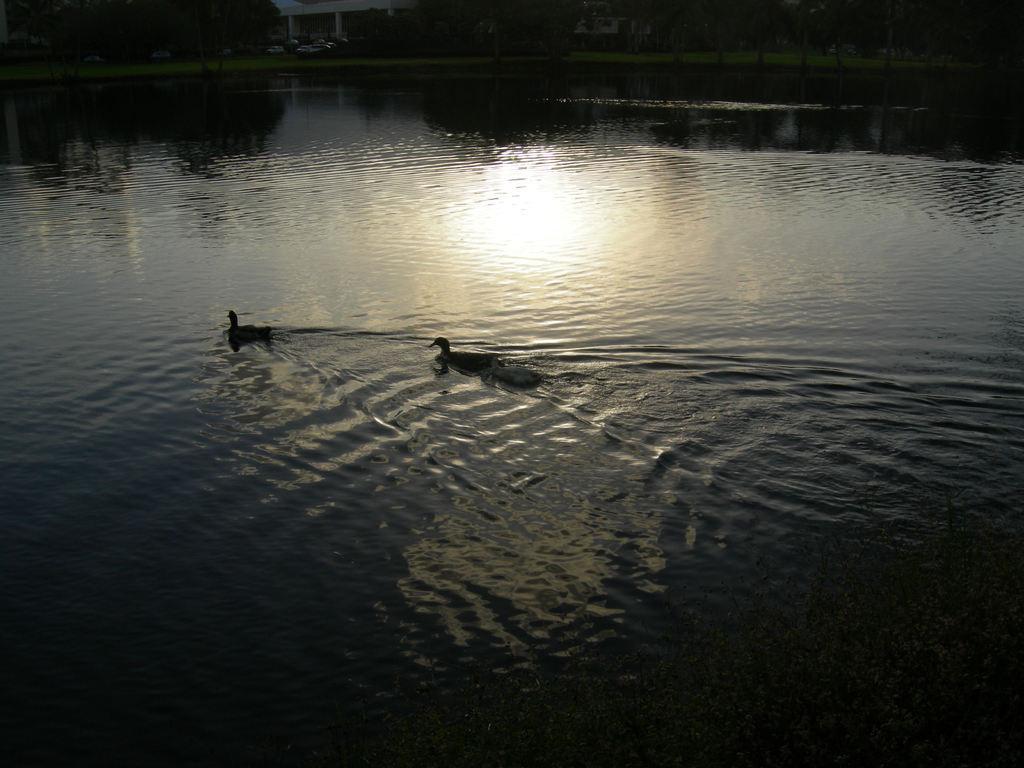In one or two sentences, can you explain what this image depicts? In this image we can see ducks in the water. In the background there are trees. Also there is a building. 